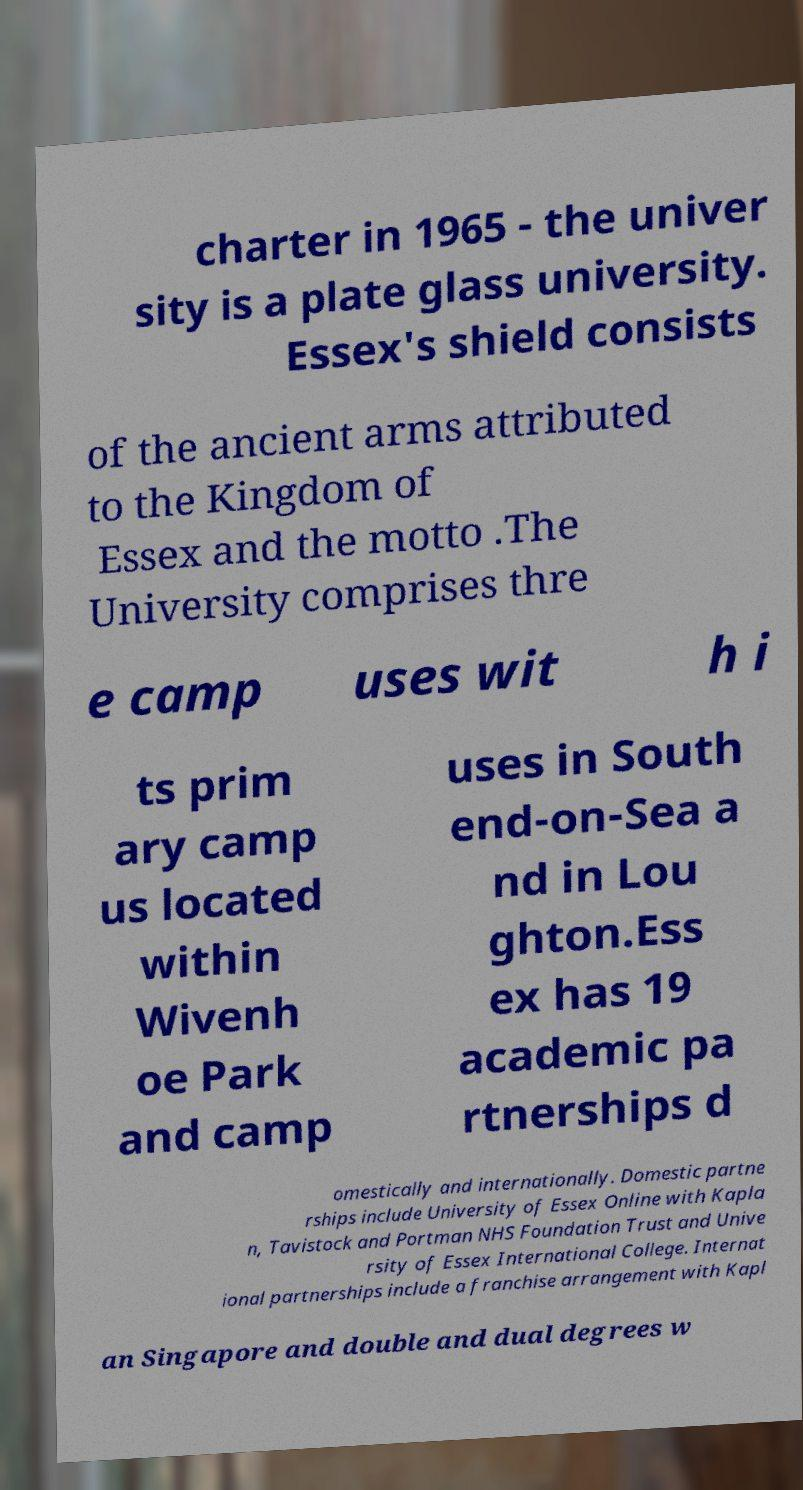Can you read and provide the text displayed in the image?This photo seems to have some interesting text. Can you extract and type it out for me? charter in 1965 - the univer sity is a plate glass university. Essex's shield consists of the ancient arms attributed to the Kingdom of Essex and the motto .The University comprises thre e camp uses wit h i ts prim ary camp us located within Wivenh oe Park and camp uses in South end-on-Sea a nd in Lou ghton.Ess ex has 19 academic pa rtnerships d omestically and internationally. Domestic partne rships include University of Essex Online with Kapla n, Tavistock and Portman NHS Foundation Trust and Unive rsity of Essex International College. Internat ional partnerships include a franchise arrangement with Kapl an Singapore and double and dual degrees w 